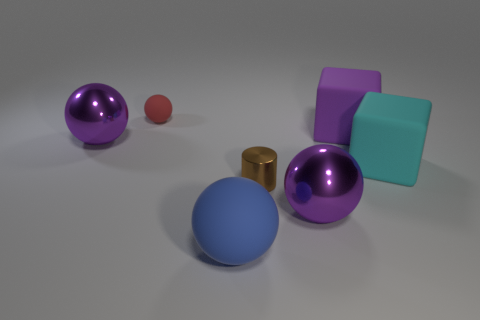What color is the rubber ball in front of the large metal sphere in front of the cyan rubber block?
Offer a very short reply. Blue. What color is the big matte thing that is on the left side of the big purple metallic object that is in front of the metallic ball behind the brown metallic object?
Your response must be concise. Blue. What number of things are purple metal balls or large cyan rubber things?
Ensure brevity in your answer.  3. What number of other tiny red matte objects have the same shape as the red object?
Give a very brief answer. 0. Do the big blue thing and the small object on the left side of the cylinder have the same material?
Offer a terse response. Yes. What is the size of the other ball that is made of the same material as the large blue sphere?
Your response must be concise. Small. There is a red matte sphere that is behind the small brown object; how big is it?
Make the answer very short. Small. What number of brown shiny things have the same size as the blue matte thing?
Your response must be concise. 0. The other metal object that is the same size as the red object is what color?
Provide a short and direct response. Brown. The cylinder has what color?
Ensure brevity in your answer.  Brown. 